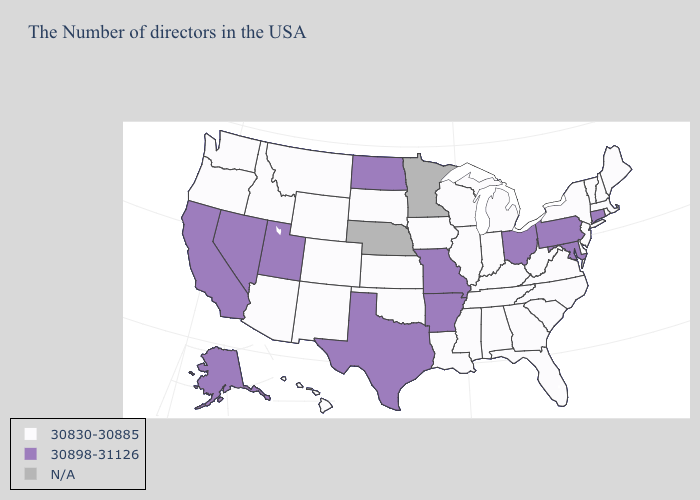What is the highest value in the USA?
Keep it brief. 30898-31126. What is the value of Georgia?
Quick response, please. 30830-30885. Name the states that have a value in the range 30830-30885?
Answer briefly. Maine, Massachusetts, Rhode Island, New Hampshire, Vermont, New York, New Jersey, Delaware, Virginia, North Carolina, South Carolina, West Virginia, Florida, Georgia, Michigan, Kentucky, Indiana, Alabama, Tennessee, Wisconsin, Illinois, Mississippi, Louisiana, Iowa, Kansas, Oklahoma, South Dakota, Wyoming, Colorado, New Mexico, Montana, Arizona, Idaho, Washington, Oregon, Hawaii. Name the states that have a value in the range N/A?
Concise answer only. Minnesota, Nebraska. Which states hav the highest value in the South?
Give a very brief answer. Maryland, Arkansas, Texas. What is the value of Vermont?
Give a very brief answer. 30830-30885. Which states have the lowest value in the South?
Concise answer only. Delaware, Virginia, North Carolina, South Carolina, West Virginia, Florida, Georgia, Kentucky, Alabama, Tennessee, Mississippi, Louisiana, Oklahoma. Among the states that border Colorado , does Kansas have the highest value?
Quick response, please. No. Is the legend a continuous bar?
Concise answer only. No. What is the lowest value in the West?
Answer briefly. 30830-30885. What is the lowest value in the USA?
Be succinct. 30830-30885. What is the highest value in the MidWest ?
Short answer required. 30898-31126. What is the value of Georgia?
Be succinct. 30830-30885. What is the value of Nevada?
Give a very brief answer. 30898-31126. What is the value of West Virginia?
Short answer required. 30830-30885. 